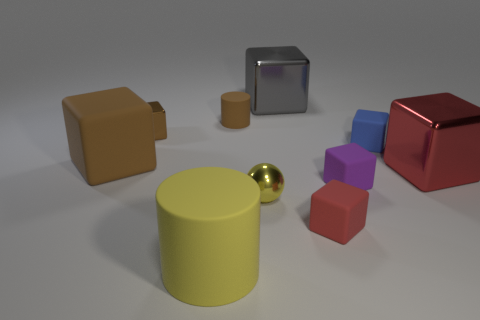Do the brown rubber thing that is to the left of the yellow cylinder and the yellow metallic thing have the same size?
Your answer should be compact. No. What number of other objects are there of the same material as the tiny brown block?
Provide a succinct answer. 3. Are there more blue rubber balls than large brown things?
Your response must be concise. No. What material is the big cube that is behind the brown object that is right of the cylinder that is in front of the brown shiny block?
Offer a terse response. Metal. Is the color of the tiny sphere the same as the small cylinder?
Keep it short and to the point. No. Is there a tiny matte cube that has the same color as the big cylinder?
Provide a succinct answer. No. There is a blue rubber thing that is the same size as the purple matte object; what shape is it?
Ensure brevity in your answer.  Cube. Are there fewer tiny blue objects than tiny green rubber cubes?
Offer a very short reply. No. What number of brown things have the same size as the gray cube?
Ensure brevity in your answer.  1. The large rubber thing that is the same color as the tiny sphere is what shape?
Make the answer very short. Cylinder. 